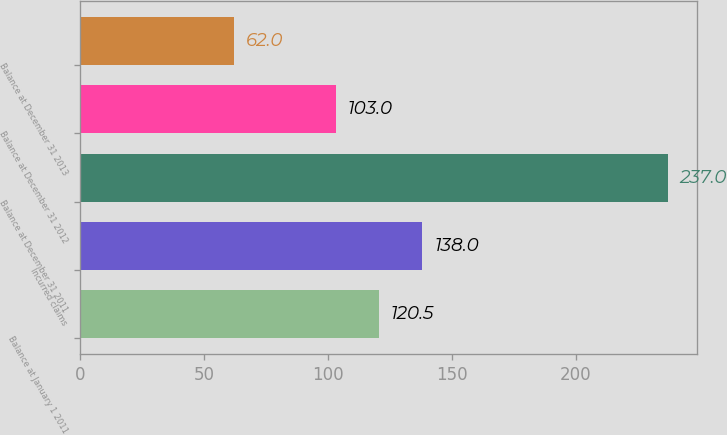Convert chart. <chart><loc_0><loc_0><loc_500><loc_500><bar_chart><fcel>Balance at January 1 2011<fcel>Incurred claims<fcel>Balance at December 31 2011<fcel>Balance at December 31 2012<fcel>Balance at December 31 2013<nl><fcel>120.5<fcel>138<fcel>237<fcel>103<fcel>62<nl></chart> 